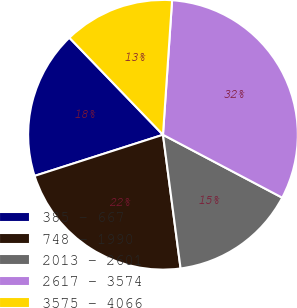Convert chart to OTSL. <chart><loc_0><loc_0><loc_500><loc_500><pie_chart><fcel>385 - 667<fcel>748 - 1990<fcel>2013 - 2601<fcel>2617 - 3574<fcel>3575 - 4066<nl><fcel>17.72%<fcel>22.15%<fcel>15.19%<fcel>31.65%<fcel>13.29%<nl></chart> 